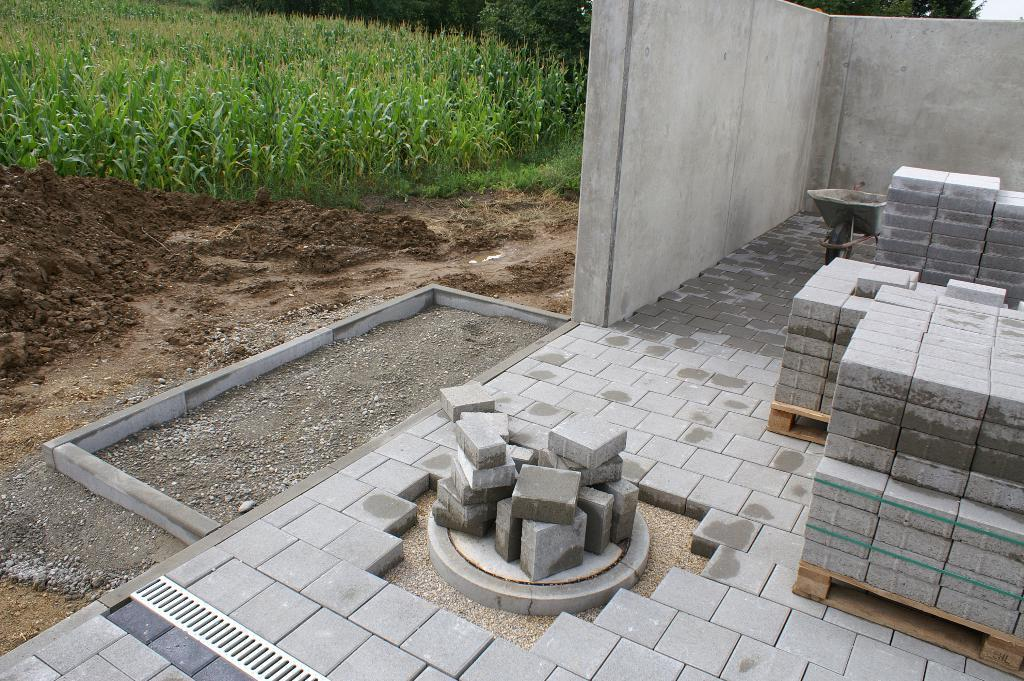What type of material is in front of the wall in the image? There are cement bricks in front of the wall in the image. What can be seen in the top left corner of the image? There is crop visible in the top left of the image. How many frogs are sitting on the stocking in the image? There are no frogs or stockings present in the image. What type of pump is visible in the image? There is no pump present in the image. 